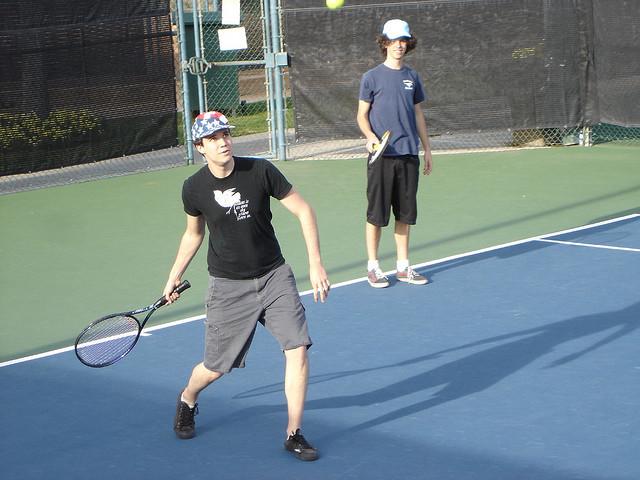How many young boys are there?
Write a very short answer. 2. Do the men have shorts on?
Be succinct. Yes. Are these guys winning the match?
Keep it brief. No. What color is the court?
Answer briefly. Blue. Are both of the men moving?
Keep it brief. No. Is this man playing tennis properly?
Give a very brief answer. Yes. How many legs are there?
Keep it brief. 4. Is the tennis player wearing a watch?
Be succinct. No. 